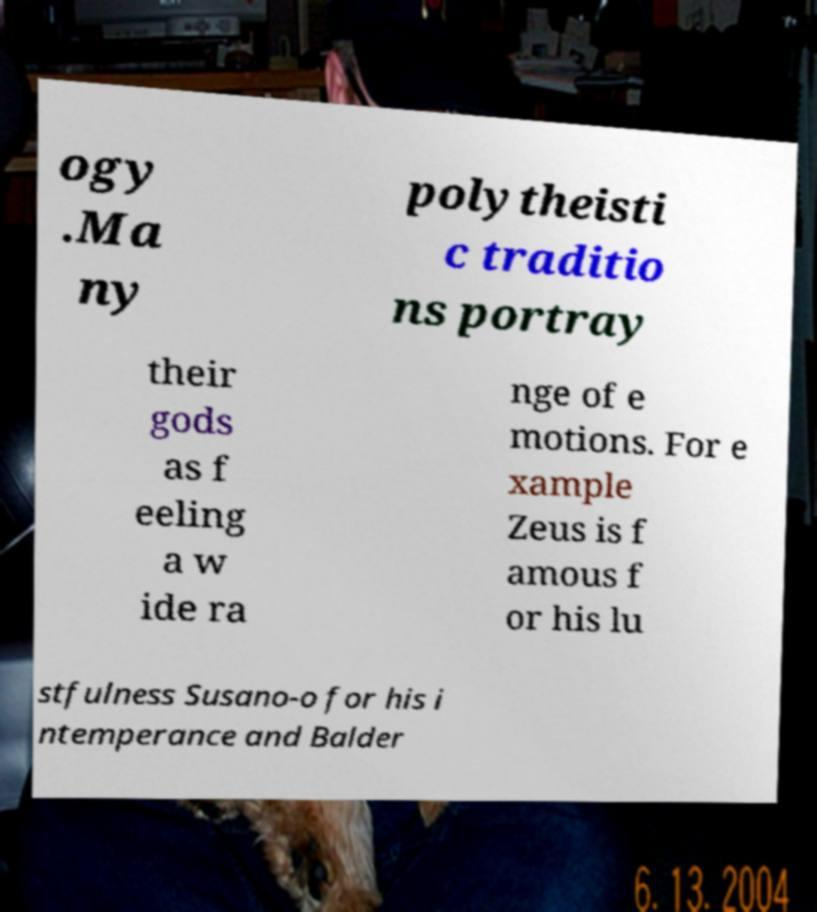For documentation purposes, I need the text within this image transcribed. Could you provide that? ogy .Ma ny polytheisti c traditio ns portray their gods as f eeling a w ide ra nge of e motions. For e xample Zeus is f amous f or his lu stfulness Susano-o for his i ntemperance and Balder 